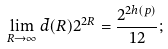Convert formula to latex. <formula><loc_0><loc_0><loc_500><loc_500>\lim _ { R \rightarrow \infty } \bar { d } ( R ) 2 ^ { 2 R } = \frac { 2 ^ { 2 h ( p ) } } { 1 2 } ;</formula> 